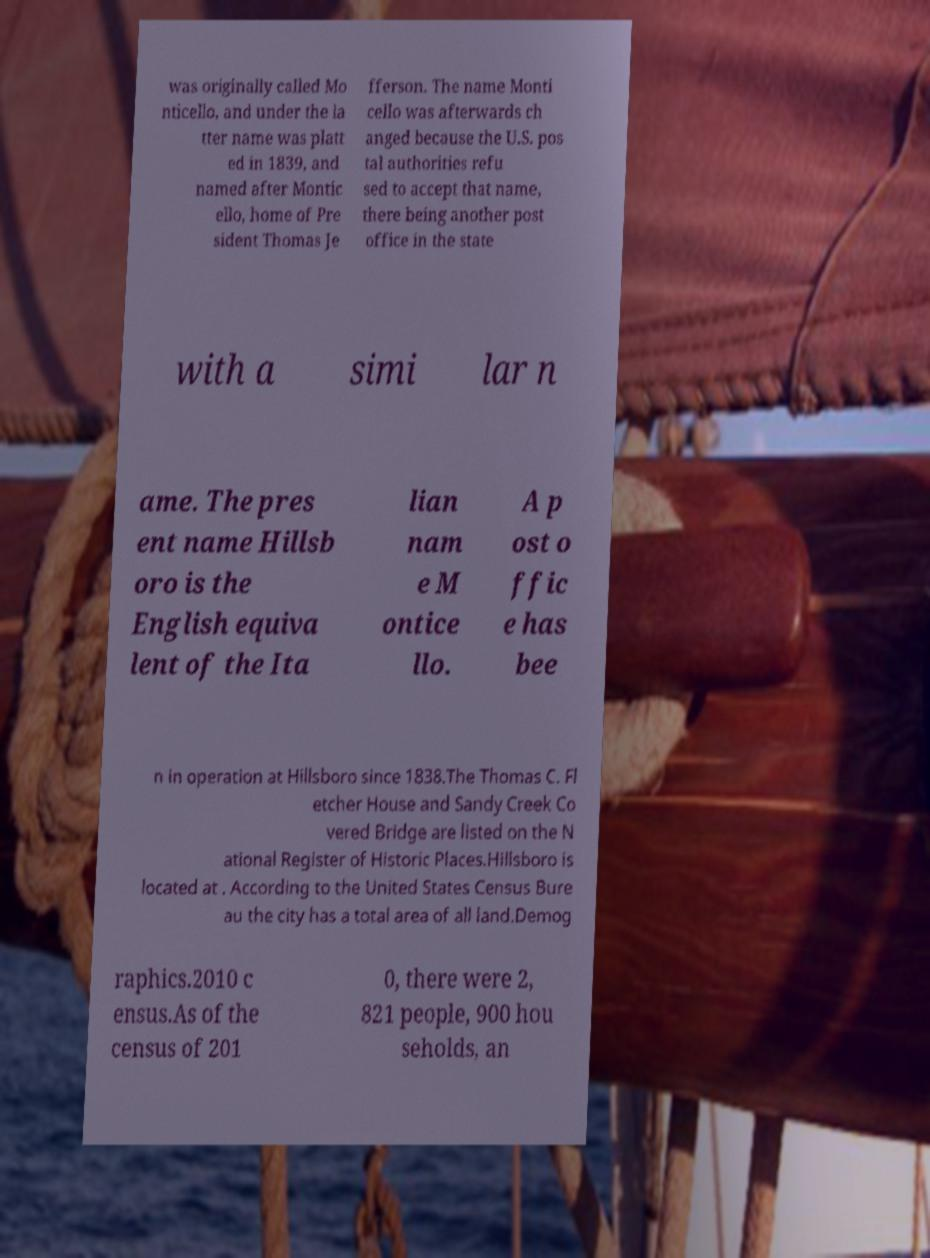Please read and relay the text visible in this image. What does it say? was originally called Mo nticello, and under the la tter name was platt ed in 1839, and named after Montic ello, home of Pre sident Thomas Je fferson. The name Monti cello was afterwards ch anged because the U.S. pos tal authorities refu sed to accept that name, there being another post office in the state with a simi lar n ame. The pres ent name Hillsb oro is the English equiva lent of the Ita lian nam e M ontice llo. A p ost o ffic e has bee n in operation at Hillsboro since 1838.The Thomas C. Fl etcher House and Sandy Creek Co vered Bridge are listed on the N ational Register of Historic Places.Hillsboro is located at . According to the United States Census Bure au the city has a total area of all land.Demog raphics.2010 c ensus.As of the census of 201 0, there were 2, 821 people, 900 hou seholds, an 